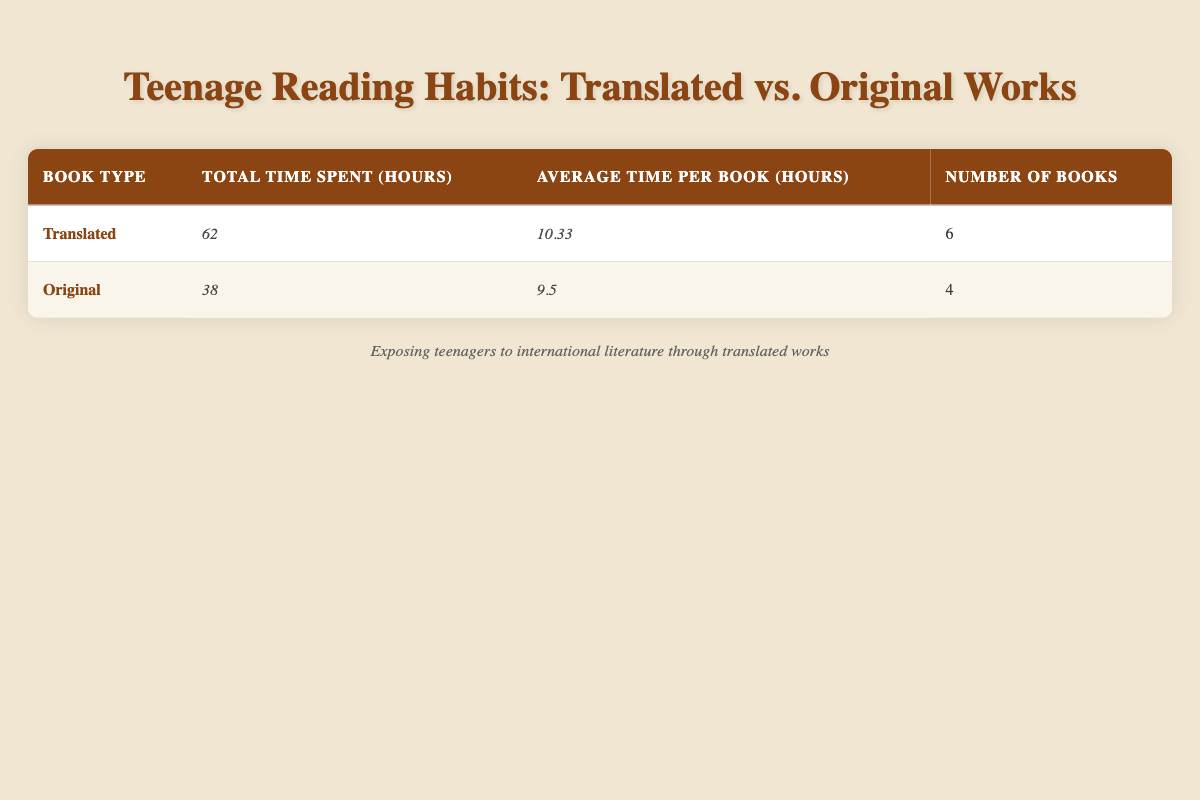What is the total time spent reading translated works? The table shows that the total time spent reading translated works is listed under the "Total Time Spent (hours)" for Translated, which is 62 hours.
Answer: 62 hours What is the average time spent on original books? The table provides the average time per book for Original works, which is explicitly listed as 9.5 hours.
Answer: 9.5 hours How many more hours do teenagers spend reading translated books compared to original books? Starting with the total times, translated books amount to 62 hours and original books to 38 hours. To find the difference, subtract 38 from 62: 62 - 38 = 24 hours.
Answer: 24 hours Does the average time spent reading translated works exceed that of original works? The average time per book for Translated is 10.33 hours while for Original it is 9.5 hours. Since 10.33 is greater than 9.5, we conclude that the average for Translated is indeed higher.
Answer: Yes How many total books are listed for each type? From the table under the "Number of Books" column, Translated works have 6 and Original works have 4.
Answer: Translated: 6, Original: 4 What is the total time spent on reading both types of books? The total time for both Translated (62 hours) and Original (38 hours) needs to be added together: 62 + 38 = 100 hours.
Answer: 100 hours What percentage of the total reading time does translated work represent? First, calculate the total reading time, which is 100 hours. The time spent on translated works is 62 hours. The percentage is calculated as (62 / 100) * 100 = 62%.
Answer: 62% Which type of books has a higher average reading time per book? Compare the averages from the table: Translated has an average of 10.33 hours and Original has an average of 9.5 hours. Since 10.33 is greater than 9.5, Translated has a higher average.
Answer: Translated Is the number of translated books read greater than the number of original books? The "Number of Books" for Translated is 6 while for Original it is 4. Since 6 is greater than 4, the statement is true.
Answer: Yes 